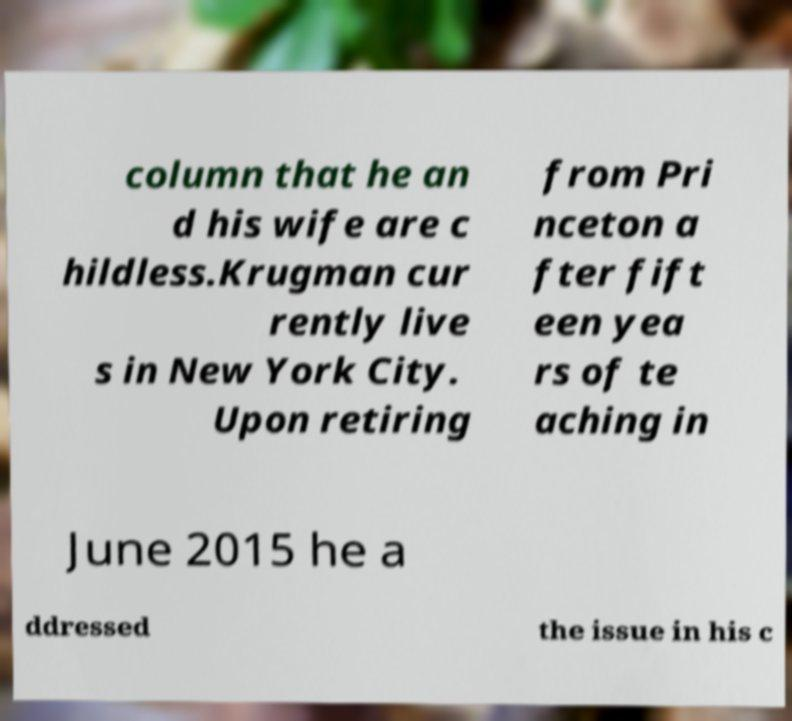Can you accurately transcribe the text from the provided image for me? column that he an d his wife are c hildless.Krugman cur rently live s in New York City. Upon retiring from Pri nceton a fter fift een yea rs of te aching in June 2015 he a ddressed the issue in his c 